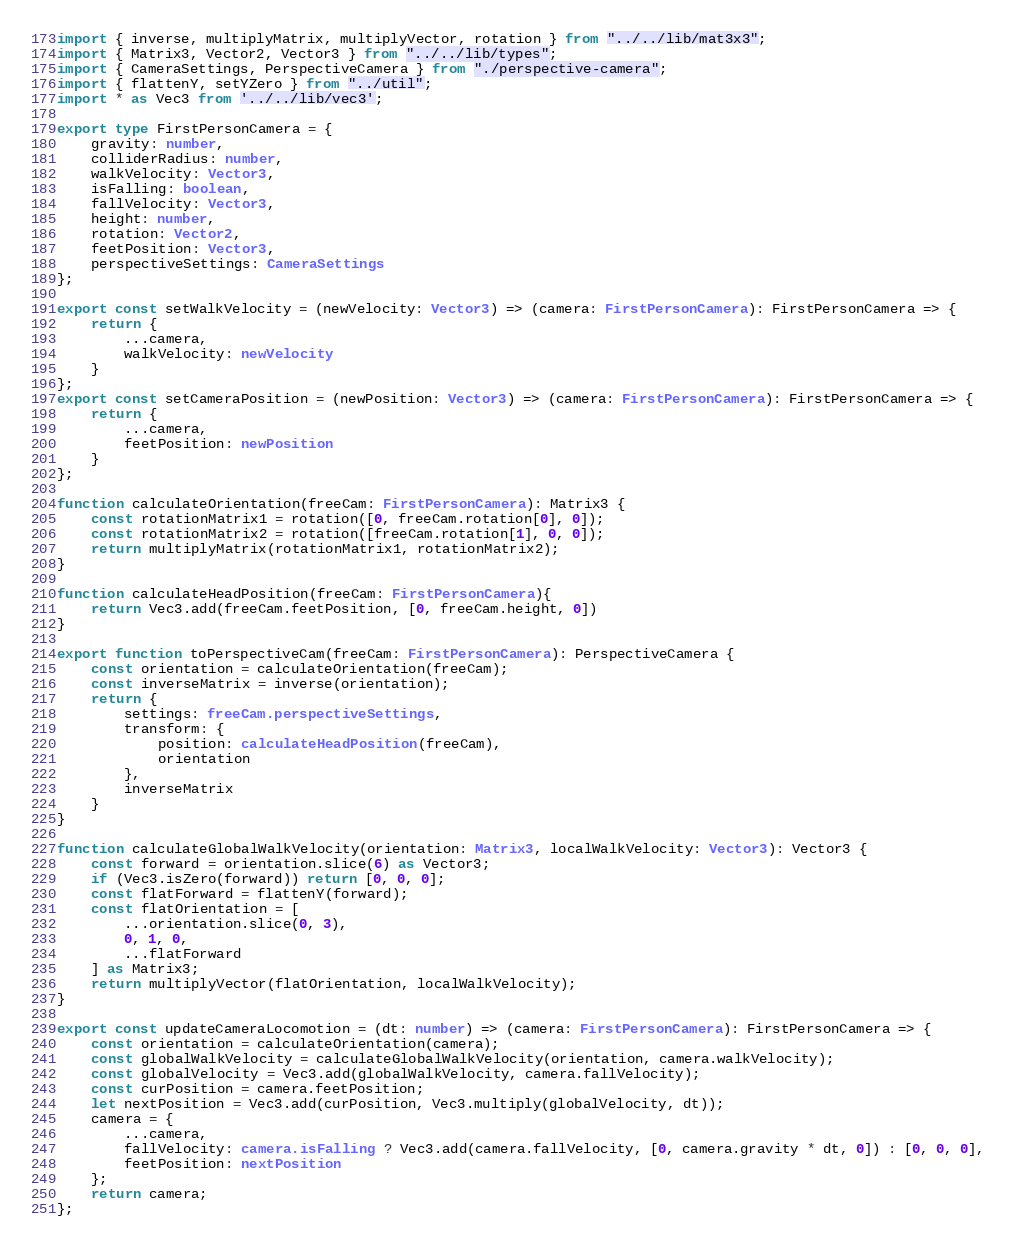Convert code to text. <code><loc_0><loc_0><loc_500><loc_500><_TypeScript_>import { inverse, multiplyMatrix, multiplyVector, rotation } from "../../lib/mat3x3";
import { Matrix3, Vector2, Vector3 } from "../../lib/types";
import { CameraSettings, PerspectiveCamera } from "./perspective-camera";
import { flattenY, setYZero } from "../util";
import * as Vec3 from '../../lib/vec3';

export type FirstPersonCamera = {
	gravity: number,
	colliderRadius: number,
	walkVelocity: Vector3,
	isFalling: boolean,
	fallVelocity: Vector3,
	height: number,
	rotation: Vector2,
	feetPosition: Vector3, 
	perspectiveSettings: CameraSettings
};

export const setWalkVelocity = (newVelocity: Vector3) => (camera: FirstPersonCamera): FirstPersonCamera => {
	return {
		...camera,
		walkVelocity: newVelocity
	}
};
export const setCameraPosition = (newPosition: Vector3) => (camera: FirstPersonCamera): FirstPersonCamera => {
	return {
		...camera,
		feetPosition: newPosition
	}
};

function calculateOrientation(freeCam: FirstPersonCamera): Matrix3 {
	const rotationMatrix1 = rotation([0, freeCam.rotation[0], 0]);
	const rotationMatrix2 = rotation([freeCam.rotation[1], 0, 0]);
	return multiplyMatrix(rotationMatrix1, rotationMatrix2);
}

function calculateHeadPosition(freeCam: FirstPersonCamera){
	return Vec3.add(freeCam.feetPosition, [0, freeCam.height, 0])
}

export function toPerspectiveCam(freeCam: FirstPersonCamera): PerspectiveCamera {
	const orientation = calculateOrientation(freeCam);
	const inverseMatrix = inverse(orientation);
	return {
		settings: freeCam.perspectiveSettings,
		transform: {
			position: calculateHeadPosition(freeCam),
			orientation
		},
		inverseMatrix
	}
}

function calculateGlobalWalkVelocity(orientation: Matrix3, localWalkVelocity: Vector3): Vector3 {
	const forward = orientation.slice(6) as Vector3;
	if (Vec3.isZero(forward)) return [0, 0, 0];
	const flatForward = flattenY(forward);
	const flatOrientation = [
		...orientation.slice(0, 3),
		0, 1, 0, 
		...flatForward
	] as Matrix3;
	return multiplyVector(flatOrientation, localWalkVelocity);
}

export const updateCameraLocomotion = (dt: number) => (camera: FirstPersonCamera): FirstPersonCamera => {
	const orientation = calculateOrientation(camera);
	const globalWalkVelocity = calculateGlobalWalkVelocity(orientation, camera.walkVelocity);
	const globalVelocity = Vec3.add(globalWalkVelocity, camera.fallVelocity);
	const curPosition = camera.feetPosition;
	let nextPosition = Vec3.add(curPosition, Vec3.multiply(globalVelocity, dt));
	camera = {
		...camera,
		fallVelocity: camera.isFalling ? Vec3.add(camera.fallVelocity, [0, camera.gravity * dt, 0]) : [0, 0, 0],
		feetPosition: nextPosition
	};
	return camera;
};</code> 